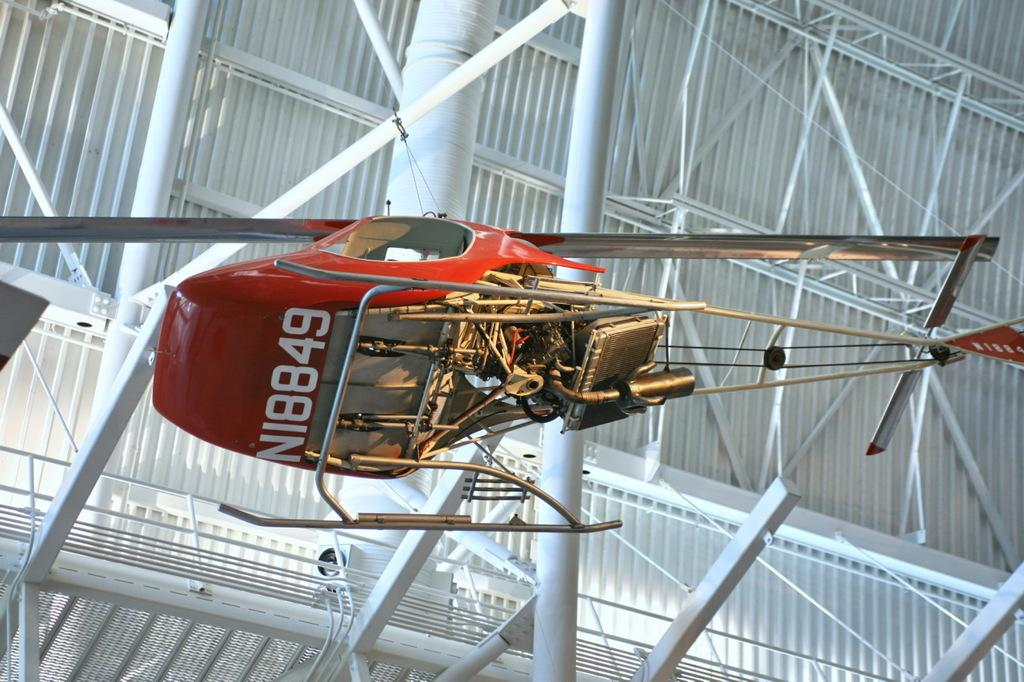What type of vehicle is in the image? There is a red helicopter in the image. Can you describe any markings or text on the helicopter? Something is written on the helicopter. What else can be seen in the image besides the helicopter? There are poles visible in the image. How many ants are crawling on the helicopter in the image? There are no ants present in the image. What type of party is happening in the image? There is no party happening in the image. 